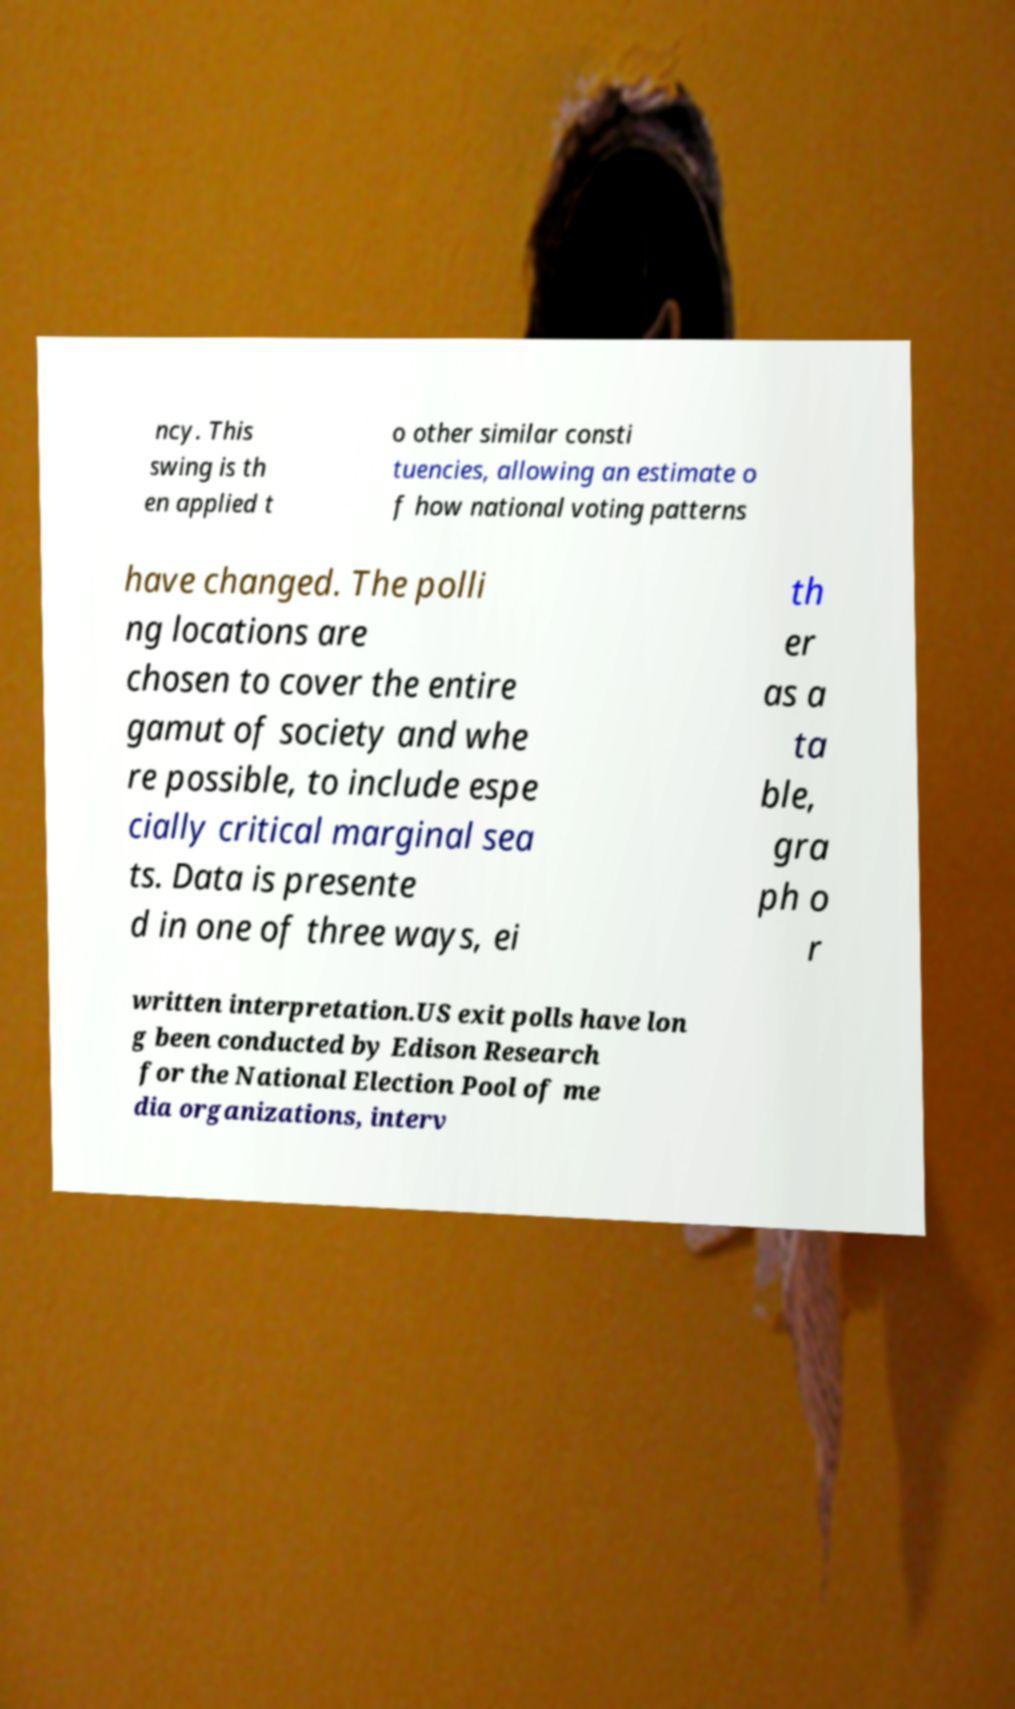Could you assist in decoding the text presented in this image and type it out clearly? ncy. This swing is th en applied t o other similar consti tuencies, allowing an estimate o f how national voting patterns have changed. The polli ng locations are chosen to cover the entire gamut of society and whe re possible, to include espe cially critical marginal sea ts. Data is presente d in one of three ways, ei th er as a ta ble, gra ph o r written interpretation.US exit polls have lon g been conducted by Edison Research for the National Election Pool of me dia organizations, interv 